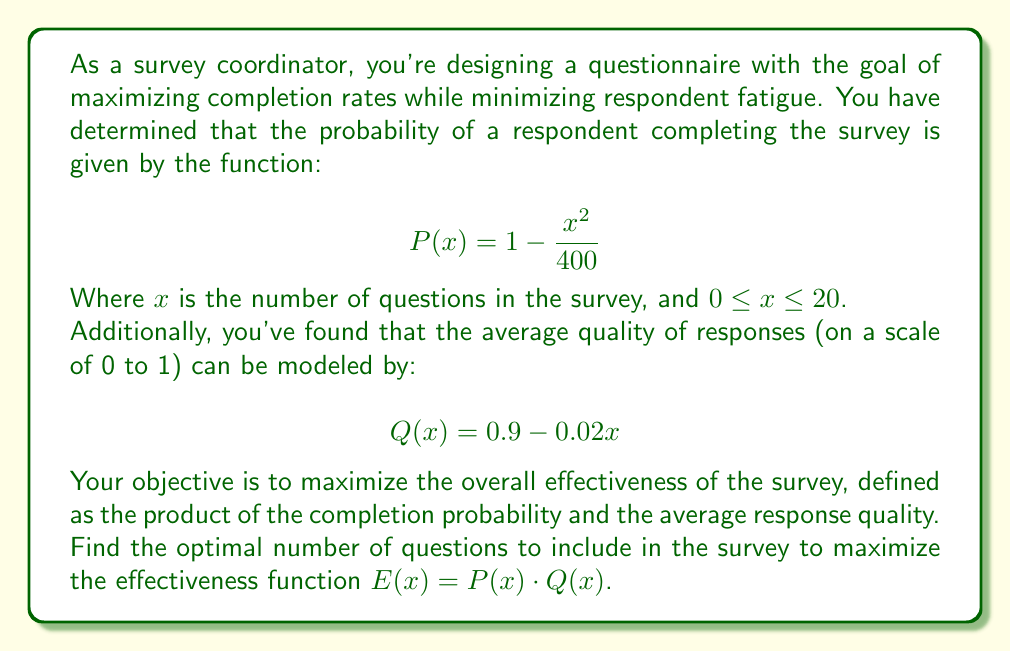Give your solution to this math problem. To solve this optimization problem, we'll follow these steps:

1) First, let's define the effectiveness function $E(x)$:

   $$E(x) = P(x) \cdot Q(x) = (1 - \frac{x^2}{400}) \cdot (0.9 - 0.02x)$$

2) Expand this equation:

   $$E(x) = (0.9 - 0.02x) - (0.9 - 0.02x)(\frac{x^2}{400})$$
   $$E(x) = 0.9 - 0.02x - \frac{0.9x^2}{400} + \frac{0.02x^3}{400}$$

3) To find the maximum, we need to find where the derivative equals zero. Let's differentiate $E(x)$:

   $$E'(x) = -0.02 - \frac{1.8x}{400} + \frac{0.06x^2}{400}$$
   $$E'(x) = -0.02 - 0.0045x + 0.00015x^2$$

4) Set this equal to zero and solve:

   $$-0.02 - 0.0045x + 0.00015x^2 = 0$$
   $$0.00015x^2 - 0.0045x - 0.02 = 0$$

5) This is a quadratic equation. We can solve it using the quadratic formula:
   
   $$x = \frac{-b \pm \sqrt{b^2 - 4ac}}{2a}$$

   Where $a = 0.00015$, $b = -0.0045$, and $c = -0.02$

6) Plugging in these values:

   $$x = \frac{0.0045 \pm \sqrt{(-0.0045)^2 - 4(0.00015)(-0.02)}}{2(0.00015)}$$
   $$x = \frac{0.0045 \pm \sqrt{0.00002025 + 0.000012}}{0.0003}$$
   $$x = \frac{0.0045 \pm \sqrt{0.00003225}}{0.0003}$$
   $$x = \frac{0.0045 \pm 0.005678}{0.0003}$$

7) This gives us two solutions:
   
   $$x_1 = \frac{0.0045 + 0.005678}{0.0003} \approx 33.93$$
   $$x_2 = \frac{0.0045 - 0.005678}{0.0003} \approx -3.93$$

8) Since $x$ represents the number of questions and must be between 0 and 20, we can discard the negative solution. The positive solution is outside our range, so we need to check the endpoints of our domain.

9) Evaluate $E(x)$ at $x = 0$, $x = 20$, and $x = 10$ (the closest integer to 33.93/2 within our range):

   $E(0) = 0.9$
   $E(10) = 0.75 \cdot 0.7 = 0.525$
   $E(20) = 0 \cdot 0.5 = 0$

10) The maximum value occurs at $x = 10$.
Answer: The optimal number of questions to include in the survey is 10. 